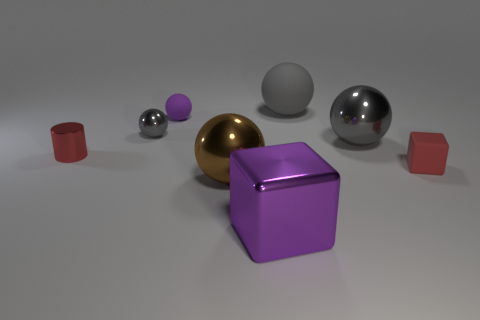There is a red object right of the metal sphere in front of the tiny red cube; what number of small red things are on the left side of it?
Your response must be concise. 1. Are there any large shiny objects left of the big gray metal thing?
Keep it short and to the point. Yes. How many purple objects are made of the same material as the small cube?
Make the answer very short. 1. What number of objects are either brown spheres or gray matte balls?
Provide a succinct answer. 2. Are any big cyan objects visible?
Provide a succinct answer. No. There is a big sphere in front of the gray metal ball that is in front of the tiny shiny thing that is to the right of the tiny red cylinder; what is its material?
Keep it short and to the point. Metal. Are there fewer big gray metal spheres that are behind the big rubber object than cyan cylinders?
Your response must be concise. No. There is a purple ball that is the same size as the red rubber thing; what material is it?
Your answer should be very brief. Rubber. What is the size of the rubber object that is both right of the brown metal ball and behind the small red metal thing?
Keep it short and to the point. Large. What is the size of the purple object that is the same shape as the red rubber object?
Your response must be concise. Large. 